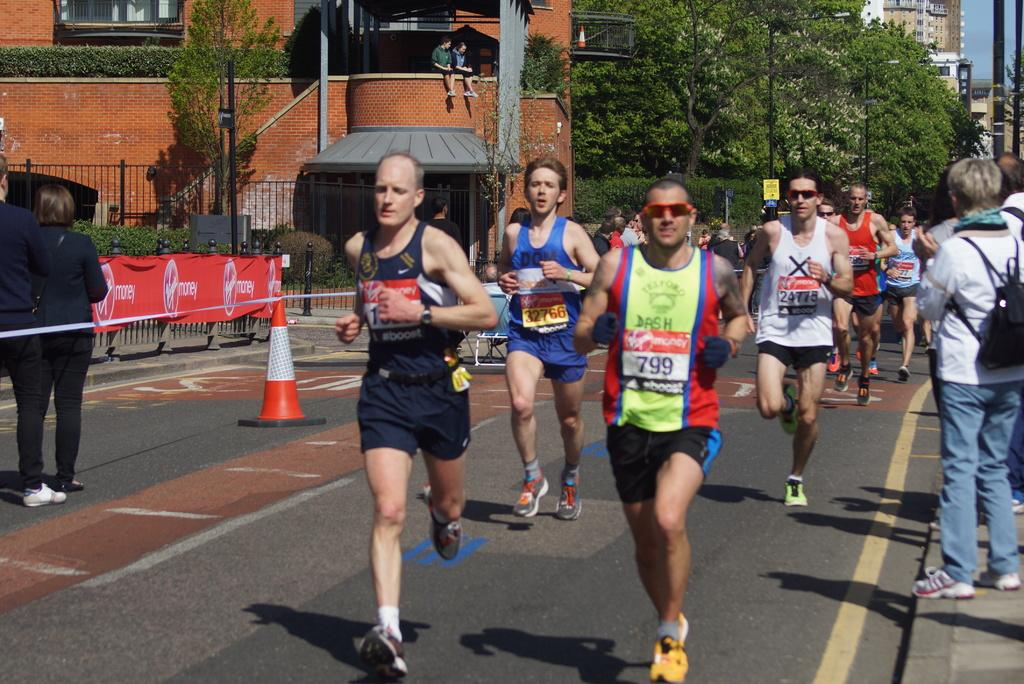What are the people in the image doing? The people in the image are running. On what surface are the people running? The people are running on a road surface. What can be seen in the background of the image? There are trees and buildings visible in the background of the image. How many legs does the boy have in the image? There is no boy present in the image, so it is not possible to determine the number of legs he might have. 